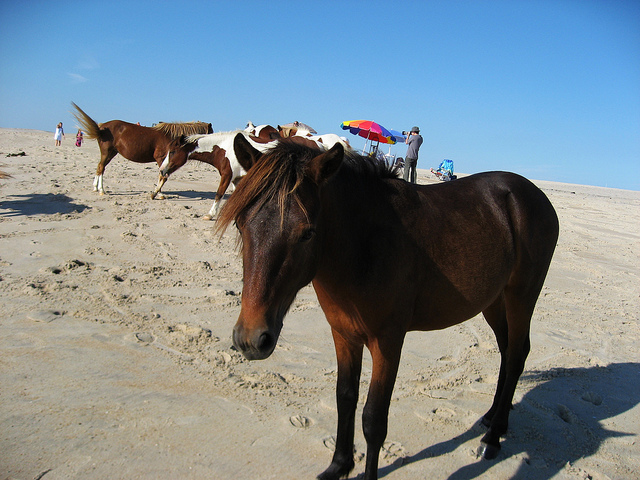Can you tell me more about the environment where these horses are found? Certainly! The horses are on a sandy beach with a clear sky above, which suggests a beautiful day for beachgoers and animals alike. The presence of a few humans and an umbrella indicate that the beach welcomes visitors, while the natural roaming of the horses suggests that this might be a protected area where wildlife is allowed to live with minimal human interruption. The dry sand and footprints indicate frequented pathways, likely both by horses and humans. 